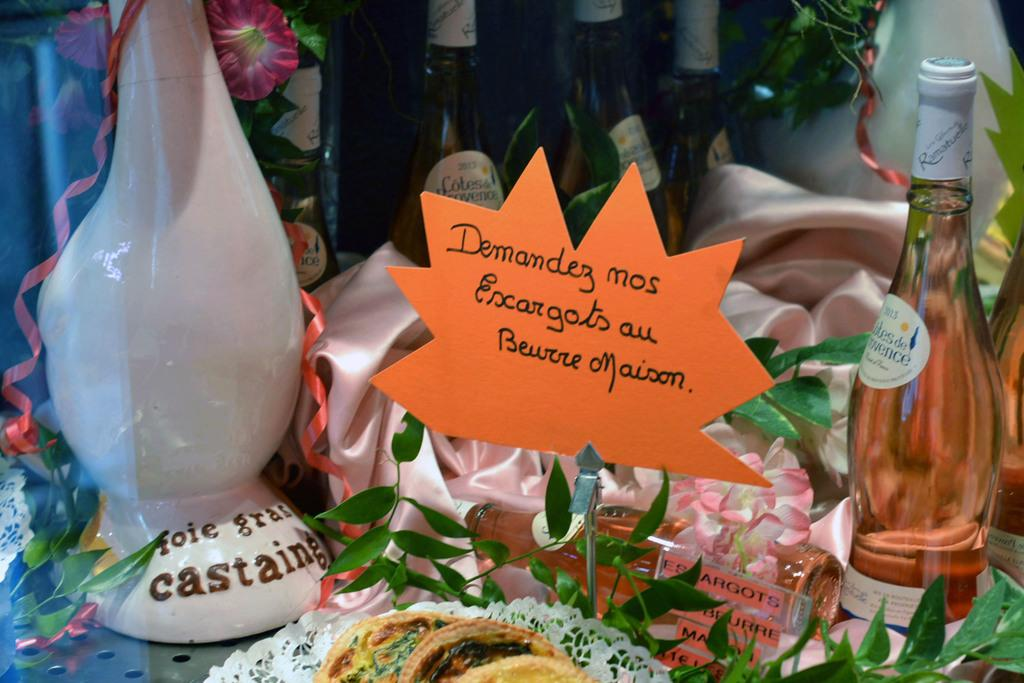<image>
Present a compact description of the photo's key features. A sign hand written in French accompanies several bottles of wine. 